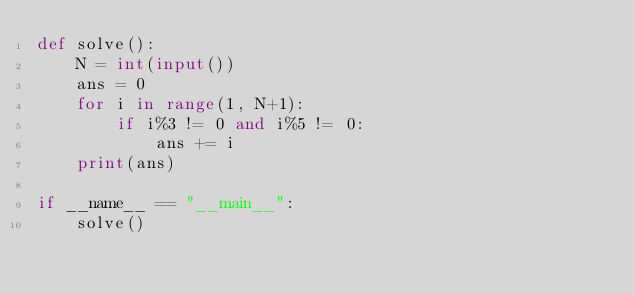<code> <loc_0><loc_0><loc_500><loc_500><_Python_>def solve():
    N = int(input())
    ans = 0
    for i in range(1, N+1):
        if i%3 != 0 and i%5 != 0:
            ans += i
    print(ans)

if __name__ == "__main__":
    solve()</code> 